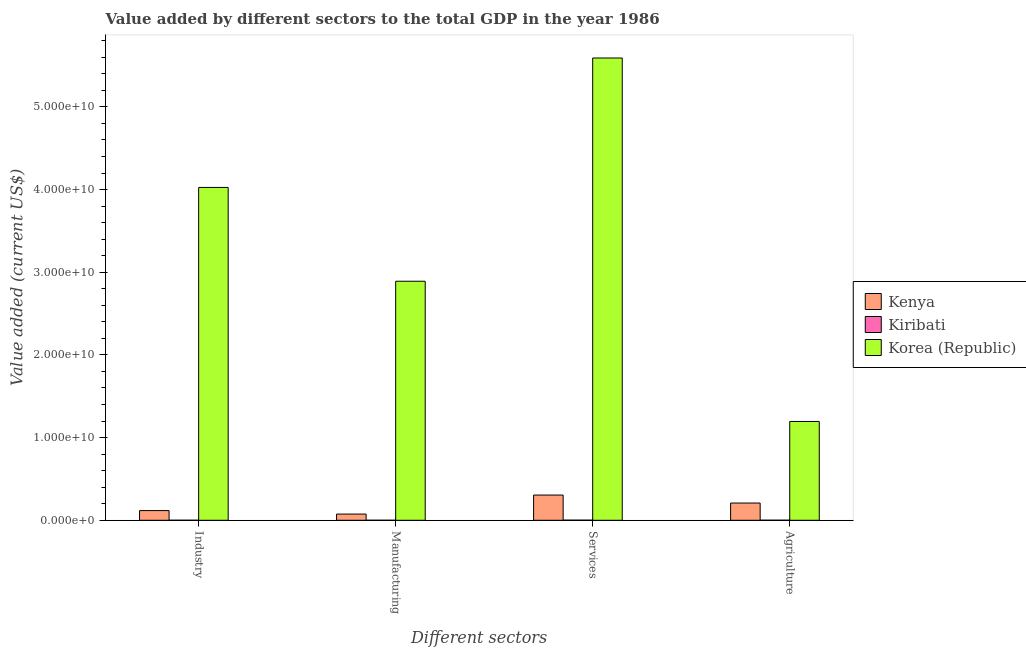Are the number of bars per tick equal to the number of legend labels?
Give a very brief answer. Yes. How many bars are there on the 4th tick from the left?
Give a very brief answer. 3. How many bars are there on the 1st tick from the right?
Provide a succinct answer. 3. What is the label of the 4th group of bars from the left?
Make the answer very short. Agriculture. What is the value added by manufacturing sector in Korea (Republic)?
Provide a succinct answer. 2.89e+1. Across all countries, what is the maximum value added by manufacturing sector?
Provide a succinct answer. 2.89e+1. Across all countries, what is the minimum value added by services sector?
Provide a succinct answer. 1.14e+07. In which country was the value added by manufacturing sector minimum?
Your answer should be compact. Kiribati. What is the total value added by services sector in the graph?
Offer a terse response. 5.90e+1. What is the difference between the value added by manufacturing sector in Kenya and that in Kiribati?
Provide a short and direct response. 7.50e+08. What is the difference between the value added by industrial sector in Kiribati and the value added by agricultural sector in Korea (Republic)?
Your answer should be compact. -1.19e+1. What is the average value added by manufacturing sector per country?
Your response must be concise. 9.89e+09. What is the difference between the value added by agricultural sector and value added by manufacturing sector in Kiribati?
Provide a short and direct response. 4.63e+06. In how many countries, is the value added by manufacturing sector greater than 30000000000 US$?
Your answer should be very brief. 0. What is the ratio of the value added by manufacturing sector in Kiribati to that in Kenya?
Your answer should be compact. 0. What is the difference between the highest and the second highest value added by services sector?
Provide a succinct answer. 5.29e+1. What is the difference between the highest and the lowest value added by manufacturing sector?
Provide a short and direct response. 2.89e+1. In how many countries, is the value added by industrial sector greater than the average value added by industrial sector taken over all countries?
Keep it short and to the point. 1. Is the sum of the value added by services sector in Kiribati and Korea (Republic) greater than the maximum value added by agricultural sector across all countries?
Your response must be concise. Yes. Is it the case that in every country, the sum of the value added by agricultural sector and value added by industrial sector is greater than the sum of value added by services sector and value added by manufacturing sector?
Ensure brevity in your answer.  No. What does the 3rd bar from the right in Industry represents?
Your response must be concise. Kenya. Is it the case that in every country, the sum of the value added by industrial sector and value added by manufacturing sector is greater than the value added by services sector?
Provide a succinct answer. No. How many bars are there?
Ensure brevity in your answer.  12. Are all the bars in the graph horizontal?
Ensure brevity in your answer.  No. How many countries are there in the graph?
Offer a terse response. 3. Are the values on the major ticks of Y-axis written in scientific E-notation?
Ensure brevity in your answer.  Yes. Does the graph contain grids?
Your answer should be very brief. No. Where does the legend appear in the graph?
Provide a short and direct response. Center right. How many legend labels are there?
Your answer should be very brief. 3. What is the title of the graph?
Provide a succinct answer. Value added by different sectors to the total GDP in the year 1986. What is the label or title of the X-axis?
Make the answer very short. Different sectors. What is the label or title of the Y-axis?
Keep it short and to the point. Value added (current US$). What is the Value added (current US$) in Kenya in Industry?
Your response must be concise. 1.17e+09. What is the Value added (current US$) in Kiribati in Industry?
Your answer should be compact. 1.56e+06. What is the Value added (current US$) in Korea (Republic) in Industry?
Your response must be concise. 4.03e+1. What is the Value added (current US$) in Kenya in Manufacturing?
Make the answer very short. 7.50e+08. What is the Value added (current US$) in Kiribati in Manufacturing?
Provide a succinct answer. 1.07e+05. What is the Value added (current US$) of Korea (Republic) in Manufacturing?
Your answer should be compact. 2.89e+1. What is the Value added (current US$) of Kenya in Services?
Give a very brief answer. 3.05e+09. What is the Value added (current US$) of Kiribati in Services?
Offer a terse response. 1.14e+07. What is the Value added (current US$) in Korea (Republic) in Services?
Ensure brevity in your answer.  5.59e+1. What is the Value added (current US$) of Kenya in Agriculture?
Provide a short and direct response. 2.08e+09. What is the Value added (current US$) in Kiribati in Agriculture?
Provide a short and direct response. 4.74e+06. What is the Value added (current US$) of Korea (Republic) in Agriculture?
Your response must be concise. 1.20e+1. Across all Different sectors, what is the maximum Value added (current US$) in Kenya?
Provide a succinct answer. 3.05e+09. Across all Different sectors, what is the maximum Value added (current US$) of Kiribati?
Keep it short and to the point. 1.14e+07. Across all Different sectors, what is the maximum Value added (current US$) in Korea (Republic)?
Offer a very short reply. 5.59e+1. Across all Different sectors, what is the minimum Value added (current US$) in Kenya?
Give a very brief answer. 7.50e+08. Across all Different sectors, what is the minimum Value added (current US$) of Kiribati?
Your answer should be compact. 1.07e+05. Across all Different sectors, what is the minimum Value added (current US$) of Korea (Republic)?
Keep it short and to the point. 1.20e+1. What is the total Value added (current US$) in Kenya in the graph?
Provide a succinct answer. 7.05e+09. What is the total Value added (current US$) of Kiribati in the graph?
Give a very brief answer. 1.78e+07. What is the total Value added (current US$) of Korea (Republic) in the graph?
Ensure brevity in your answer.  1.37e+11. What is the difference between the Value added (current US$) of Kenya in Industry and that in Manufacturing?
Provide a succinct answer. 4.22e+08. What is the difference between the Value added (current US$) of Kiribati in Industry and that in Manufacturing?
Offer a very short reply. 1.45e+06. What is the difference between the Value added (current US$) of Korea (Republic) in Industry and that in Manufacturing?
Ensure brevity in your answer.  1.13e+1. What is the difference between the Value added (current US$) of Kenya in Industry and that in Services?
Give a very brief answer. -1.88e+09. What is the difference between the Value added (current US$) in Kiribati in Industry and that in Services?
Keep it short and to the point. -9.86e+06. What is the difference between the Value added (current US$) of Korea (Republic) in Industry and that in Services?
Provide a succinct answer. -1.57e+1. What is the difference between the Value added (current US$) in Kenya in Industry and that in Agriculture?
Provide a succinct answer. -9.12e+08. What is the difference between the Value added (current US$) of Kiribati in Industry and that in Agriculture?
Your response must be concise. -3.18e+06. What is the difference between the Value added (current US$) in Korea (Republic) in Industry and that in Agriculture?
Provide a short and direct response. 2.83e+1. What is the difference between the Value added (current US$) of Kenya in Manufacturing and that in Services?
Keep it short and to the point. -2.30e+09. What is the difference between the Value added (current US$) in Kiribati in Manufacturing and that in Services?
Offer a very short reply. -1.13e+07. What is the difference between the Value added (current US$) of Korea (Republic) in Manufacturing and that in Services?
Your response must be concise. -2.70e+1. What is the difference between the Value added (current US$) of Kenya in Manufacturing and that in Agriculture?
Keep it short and to the point. -1.33e+09. What is the difference between the Value added (current US$) in Kiribati in Manufacturing and that in Agriculture?
Offer a very short reply. -4.63e+06. What is the difference between the Value added (current US$) of Korea (Republic) in Manufacturing and that in Agriculture?
Provide a short and direct response. 1.70e+1. What is the difference between the Value added (current US$) in Kenya in Services and that in Agriculture?
Your answer should be very brief. 9.67e+08. What is the difference between the Value added (current US$) in Kiribati in Services and that in Agriculture?
Keep it short and to the point. 6.68e+06. What is the difference between the Value added (current US$) of Korea (Republic) in Services and that in Agriculture?
Offer a very short reply. 4.40e+1. What is the difference between the Value added (current US$) in Kenya in Industry and the Value added (current US$) in Kiribati in Manufacturing?
Your response must be concise. 1.17e+09. What is the difference between the Value added (current US$) in Kenya in Industry and the Value added (current US$) in Korea (Republic) in Manufacturing?
Give a very brief answer. -2.77e+1. What is the difference between the Value added (current US$) of Kiribati in Industry and the Value added (current US$) of Korea (Republic) in Manufacturing?
Offer a very short reply. -2.89e+1. What is the difference between the Value added (current US$) in Kenya in Industry and the Value added (current US$) in Kiribati in Services?
Offer a very short reply. 1.16e+09. What is the difference between the Value added (current US$) of Kenya in Industry and the Value added (current US$) of Korea (Republic) in Services?
Offer a very short reply. -5.47e+1. What is the difference between the Value added (current US$) of Kiribati in Industry and the Value added (current US$) of Korea (Republic) in Services?
Offer a very short reply. -5.59e+1. What is the difference between the Value added (current US$) of Kenya in Industry and the Value added (current US$) of Kiribati in Agriculture?
Give a very brief answer. 1.17e+09. What is the difference between the Value added (current US$) of Kenya in Industry and the Value added (current US$) of Korea (Republic) in Agriculture?
Offer a terse response. -1.08e+1. What is the difference between the Value added (current US$) in Kiribati in Industry and the Value added (current US$) in Korea (Republic) in Agriculture?
Offer a terse response. -1.19e+1. What is the difference between the Value added (current US$) of Kenya in Manufacturing and the Value added (current US$) of Kiribati in Services?
Give a very brief answer. 7.38e+08. What is the difference between the Value added (current US$) in Kenya in Manufacturing and the Value added (current US$) in Korea (Republic) in Services?
Your answer should be compact. -5.52e+1. What is the difference between the Value added (current US$) in Kiribati in Manufacturing and the Value added (current US$) in Korea (Republic) in Services?
Your answer should be compact. -5.59e+1. What is the difference between the Value added (current US$) in Kenya in Manufacturing and the Value added (current US$) in Kiribati in Agriculture?
Offer a very short reply. 7.45e+08. What is the difference between the Value added (current US$) in Kenya in Manufacturing and the Value added (current US$) in Korea (Republic) in Agriculture?
Make the answer very short. -1.12e+1. What is the difference between the Value added (current US$) of Kiribati in Manufacturing and the Value added (current US$) of Korea (Republic) in Agriculture?
Offer a very short reply. -1.20e+1. What is the difference between the Value added (current US$) of Kenya in Services and the Value added (current US$) of Kiribati in Agriculture?
Ensure brevity in your answer.  3.05e+09. What is the difference between the Value added (current US$) in Kenya in Services and the Value added (current US$) in Korea (Republic) in Agriculture?
Keep it short and to the point. -8.90e+09. What is the difference between the Value added (current US$) in Kiribati in Services and the Value added (current US$) in Korea (Republic) in Agriculture?
Provide a succinct answer. -1.19e+1. What is the average Value added (current US$) in Kenya per Different sectors?
Your response must be concise. 1.76e+09. What is the average Value added (current US$) of Kiribati per Different sectors?
Your answer should be compact. 4.46e+06. What is the average Value added (current US$) in Korea (Republic) per Different sectors?
Offer a terse response. 3.43e+1. What is the difference between the Value added (current US$) of Kenya and Value added (current US$) of Kiribati in Industry?
Make the answer very short. 1.17e+09. What is the difference between the Value added (current US$) of Kenya and Value added (current US$) of Korea (Republic) in Industry?
Offer a terse response. -3.91e+1. What is the difference between the Value added (current US$) of Kiribati and Value added (current US$) of Korea (Republic) in Industry?
Offer a very short reply. -4.03e+1. What is the difference between the Value added (current US$) in Kenya and Value added (current US$) in Kiribati in Manufacturing?
Offer a terse response. 7.50e+08. What is the difference between the Value added (current US$) in Kenya and Value added (current US$) in Korea (Republic) in Manufacturing?
Offer a terse response. -2.82e+1. What is the difference between the Value added (current US$) of Kiribati and Value added (current US$) of Korea (Republic) in Manufacturing?
Offer a terse response. -2.89e+1. What is the difference between the Value added (current US$) of Kenya and Value added (current US$) of Kiribati in Services?
Provide a succinct answer. 3.04e+09. What is the difference between the Value added (current US$) of Kenya and Value added (current US$) of Korea (Republic) in Services?
Ensure brevity in your answer.  -5.29e+1. What is the difference between the Value added (current US$) of Kiribati and Value added (current US$) of Korea (Republic) in Services?
Make the answer very short. -5.59e+1. What is the difference between the Value added (current US$) of Kenya and Value added (current US$) of Kiribati in Agriculture?
Your answer should be very brief. 2.08e+09. What is the difference between the Value added (current US$) of Kenya and Value added (current US$) of Korea (Republic) in Agriculture?
Give a very brief answer. -9.87e+09. What is the difference between the Value added (current US$) of Kiribati and Value added (current US$) of Korea (Republic) in Agriculture?
Your answer should be very brief. -1.19e+1. What is the ratio of the Value added (current US$) in Kenya in Industry to that in Manufacturing?
Your answer should be compact. 1.56. What is the ratio of the Value added (current US$) in Kiribati in Industry to that in Manufacturing?
Provide a short and direct response. 14.57. What is the ratio of the Value added (current US$) of Korea (Republic) in Industry to that in Manufacturing?
Your answer should be very brief. 1.39. What is the ratio of the Value added (current US$) of Kenya in Industry to that in Services?
Give a very brief answer. 0.38. What is the ratio of the Value added (current US$) in Kiribati in Industry to that in Services?
Offer a very short reply. 0.14. What is the ratio of the Value added (current US$) in Korea (Republic) in Industry to that in Services?
Your answer should be compact. 0.72. What is the ratio of the Value added (current US$) of Kenya in Industry to that in Agriculture?
Offer a very short reply. 0.56. What is the ratio of the Value added (current US$) in Kiribati in Industry to that in Agriculture?
Offer a terse response. 0.33. What is the ratio of the Value added (current US$) in Korea (Republic) in Industry to that in Agriculture?
Your answer should be compact. 3.37. What is the ratio of the Value added (current US$) in Kenya in Manufacturing to that in Services?
Provide a succinct answer. 0.25. What is the ratio of the Value added (current US$) in Kiribati in Manufacturing to that in Services?
Your answer should be compact. 0.01. What is the ratio of the Value added (current US$) of Korea (Republic) in Manufacturing to that in Services?
Offer a terse response. 0.52. What is the ratio of the Value added (current US$) of Kenya in Manufacturing to that in Agriculture?
Your response must be concise. 0.36. What is the ratio of the Value added (current US$) in Kiribati in Manufacturing to that in Agriculture?
Offer a terse response. 0.02. What is the ratio of the Value added (current US$) in Korea (Republic) in Manufacturing to that in Agriculture?
Provide a succinct answer. 2.42. What is the ratio of the Value added (current US$) of Kenya in Services to that in Agriculture?
Provide a short and direct response. 1.46. What is the ratio of the Value added (current US$) in Kiribati in Services to that in Agriculture?
Ensure brevity in your answer.  2.41. What is the ratio of the Value added (current US$) of Korea (Republic) in Services to that in Agriculture?
Provide a short and direct response. 4.68. What is the difference between the highest and the second highest Value added (current US$) in Kenya?
Offer a very short reply. 9.67e+08. What is the difference between the highest and the second highest Value added (current US$) in Kiribati?
Offer a terse response. 6.68e+06. What is the difference between the highest and the second highest Value added (current US$) of Korea (Republic)?
Make the answer very short. 1.57e+1. What is the difference between the highest and the lowest Value added (current US$) of Kenya?
Give a very brief answer. 2.30e+09. What is the difference between the highest and the lowest Value added (current US$) of Kiribati?
Your answer should be compact. 1.13e+07. What is the difference between the highest and the lowest Value added (current US$) in Korea (Republic)?
Provide a succinct answer. 4.40e+1. 